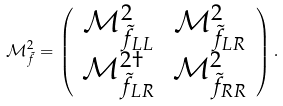Convert formula to latex. <formula><loc_0><loc_0><loc_500><loc_500>\mathcal { M } _ { \tilde { f } } ^ { 2 } = \left ( \begin{array} { c c } \mathcal { M } _ { \tilde { f } _ { L L } } ^ { 2 } & \mathcal { M } _ { \tilde { f } _ { L R } } ^ { 2 } \\ \mathcal { M } _ { \tilde { f } _ { L R } } ^ { 2 \dagger } & \mathcal { M } _ { \tilde { f } _ { R R } } ^ { 2 } \end{array} \right ) .</formula> 